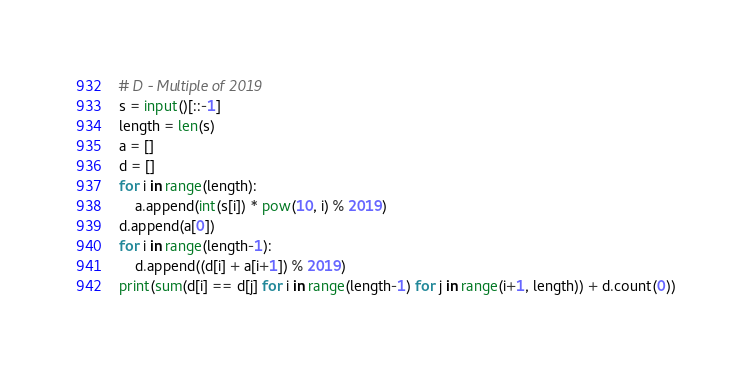<code> <loc_0><loc_0><loc_500><loc_500><_Python_># D - Multiple of 2019
s = input()[::-1]
length = len(s)
a = []
d = []
for i in range(length):
    a.append(int(s[i]) * pow(10, i) % 2019)
d.append(a[0])
for i in range(length-1):
    d.append((d[i] + a[i+1]) % 2019)
print(sum(d[i] == d[j] for i in range(length-1) for j in range(i+1, length)) + d.count(0))</code> 